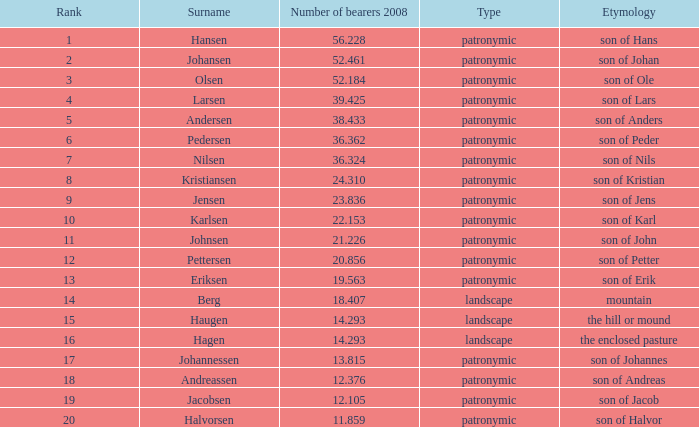What is Type, when Number of Bearers 2008 is greater than 12.376, when Rank is greater than 3, and when Etymology is Son of Jens? Patronymic. 